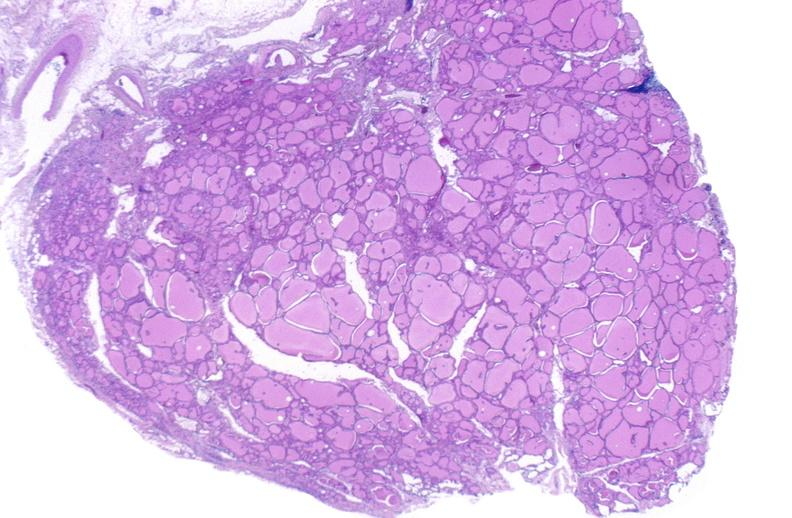what is present?
Answer the question using a single word or phrase. Endocrine 